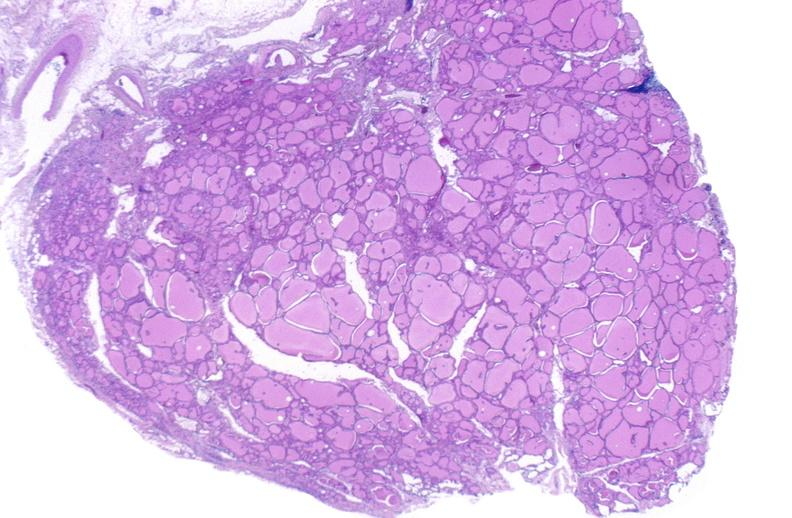what is present?
Answer the question using a single word or phrase. Endocrine 